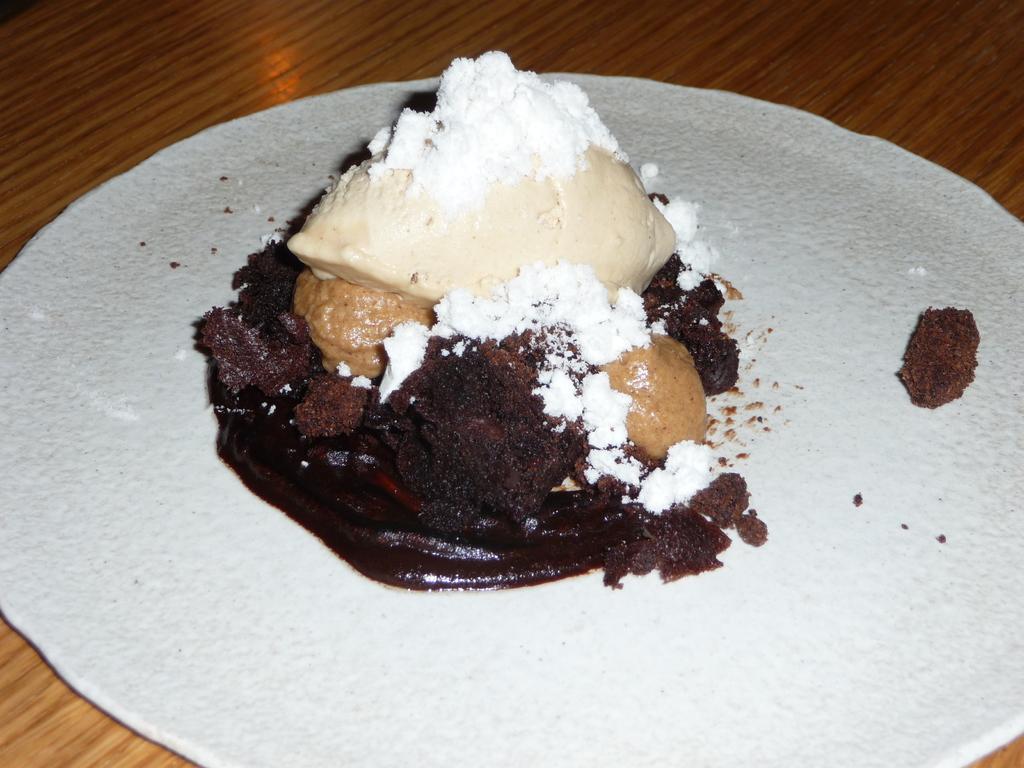Could you give a brief overview of what you see in this image? There is a wooden table. On that there is a white surface. On that there is a food item with chocolate, white powder and some other things. 